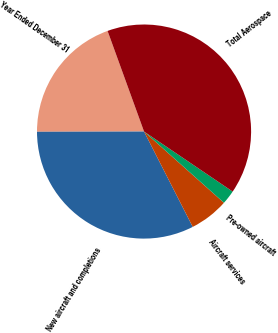Convert chart. <chart><loc_0><loc_0><loc_500><loc_500><pie_chart><fcel>Year Ended December 31<fcel>New aircraft and completions<fcel>Aircraft services<fcel>Pre-owned aircraft<fcel>Total Aerospace<nl><fcel>19.5%<fcel>32.48%<fcel>5.9%<fcel>2.11%<fcel>40.01%<nl></chart> 